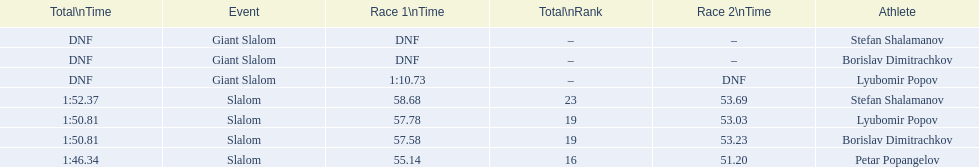What are all the competitions lyubomir popov competed in? Lyubomir Popov, Lyubomir Popov. Of those, which were giant slalom races? Giant Slalom. What was his time in race 1? 1:10.73. 